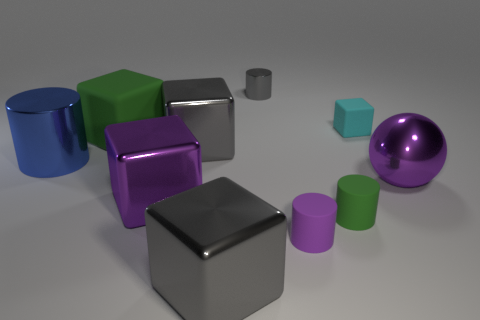How many gray cubes must be subtracted to get 1 gray cubes? 1 Subtract 1 cylinders. How many cylinders are left? 3 Subtract all purple blocks. How many blocks are left? 4 Subtract all red blocks. Subtract all purple cylinders. How many blocks are left? 5 Subtract all cylinders. How many objects are left? 6 Subtract 0 green spheres. How many objects are left? 10 Subtract all cyan matte blocks. Subtract all big purple metal things. How many objects are left? 7 Add 4 small rubber blocks. How many small rubber blocks are left? 5 Add 3 matte objects. How many matte objects exist? 7 